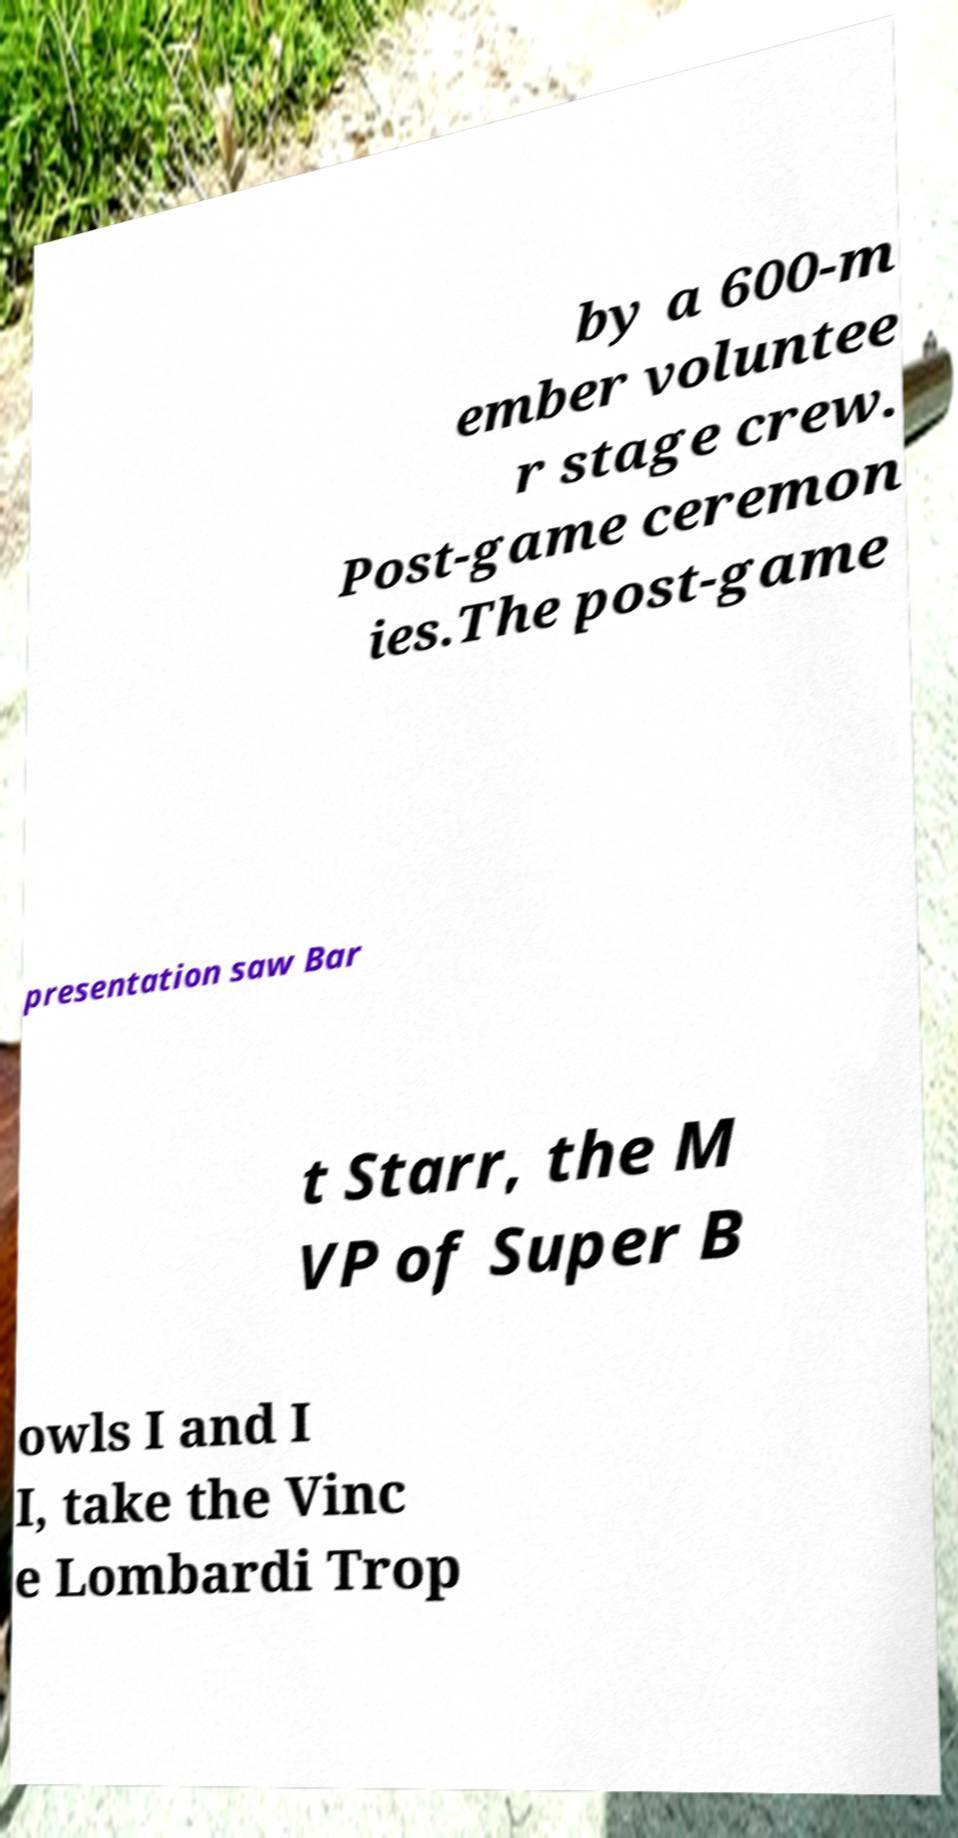Please read and relay the text visible in this image. What does it say? by a 600-m ember voluntee r stage crew. Post-game ceremon ies.The post-game presentation saw Bar t Starr, the M VP of Super B owls I and I I, take the Vinc e Lombardi Trop 